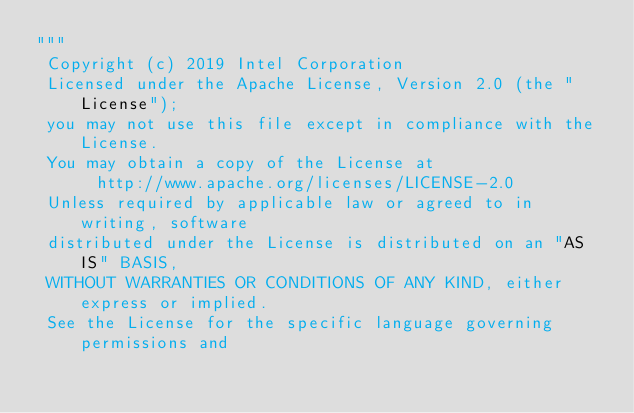<code> <loc_0><loc_0><loc_500><loc_500><_Python_>"""
 Copyright (c) 2019 Intel Corporation
 Licensed under the Apache License, Version 2.0 (the "License");
 you may not use this file except in compliance with the License.
 You may obtain a copy of the License at
      http://www.apache.org/licenses/LICENSE-2.0
 Unless required by applicable law or agreed to in writing, software
 distributed under the License is distributed on an "AS IS" BASIS,
 WITHOUT WARRANTIES OR CONDITIONS OF ANY KIND, either express or implied.
 See the License for the specific language governing permissions and</code> 